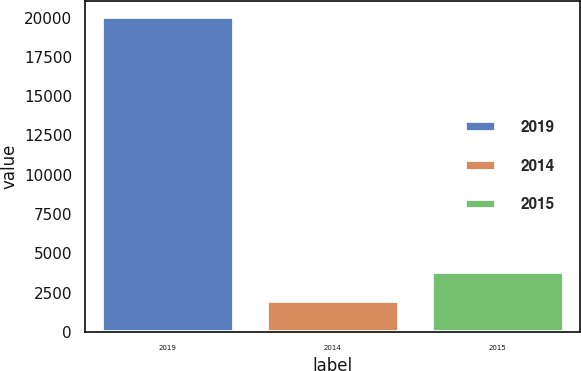Convert chart. <chart><loc_0><loc_0><loc_500><loc_500><bar_chart><fcel>2019<fcel>2014<fcel>2015<nl><fcel>20041<fcel>1994<fcel>3798.7<nl></chart> 